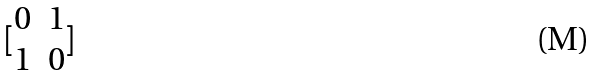Convert formula to latex. <formula><loc_0><loc_0><loc_500><loc_500>[ \begin{matrix} 0 & 1 \\ 1 & 0 \end{matrix} ]</formula> 